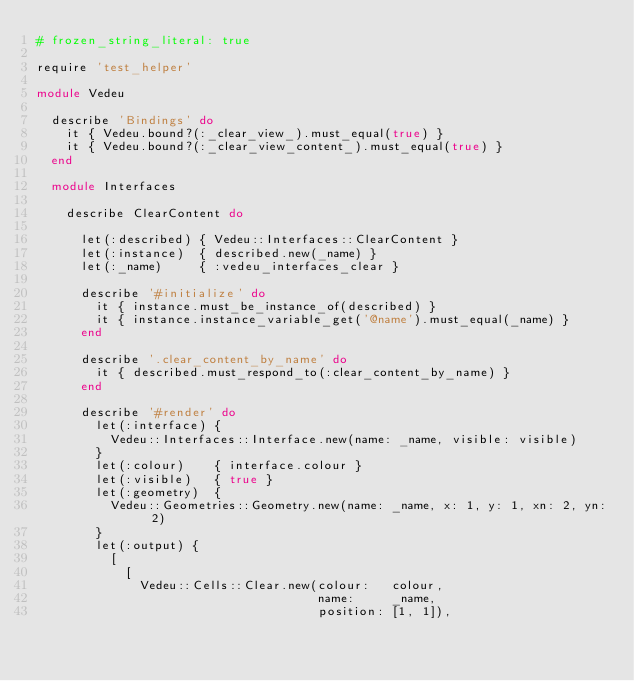Convert code to text. <code><loc_0><loc_0><loc_500><loc_500><_Ruby_># frozen_string_literal: true

require 'test_helper'

module Vedeu

  describe 'Bindings' do
    it { Vedeu.bound?(:_clear_view_).must_equal(true) }
    it { Vedeu.bound?(:_clear_view_content_).must_equal(true) }
  end

  module Interfaces

    describe ClearContent do

      let(:described) { Vedeu::Interfaces::ClearContent }
      let(:instance)  { described.new(_name) }
      let(:_name)     { :vedeu_interfaces_clear }

      describe '#initialize' do
        it { instance.must_be_instance_of(described) }
        it { instance.instance_variable_get('@name').must_equal(_name) }
      end

      describe '.clear_content_by_name' do
        it { described.must_respond_to(:clear_content_by_name) }
      end

      describe '#render' do
        let(:interface) {
          Vedeu::Interfaces::Interface.new(name: _name, visible: visible)
        }
        let(:colour)    { interface.colour }
        let(:visible)   { true }
        let(:geometry)  {
          Vedeu::Geometries::Geometry.new(name: _name, x: 1, y: 1, xn: 2, yn: 2)
        }
        let(:output) {
          [
            [
              Vedeu::Cells::Clear.new(colour:   colour,
                                      name:     _name,
                                      position: [1, 1]),</code> 